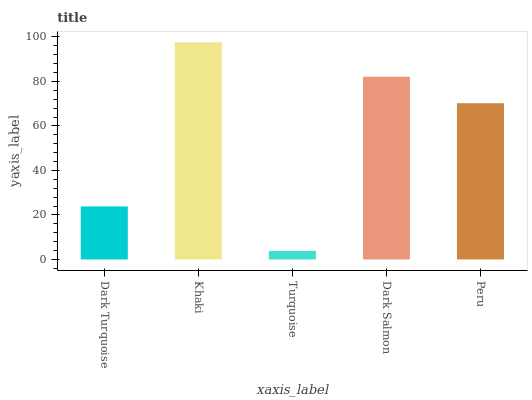Is Turquoise the minimum?
Answer yes or no. Yes. Is Khaki the maximum?
Answer yes or no. Yes. Is Khaki the minimum?
Answer yes or no. No. Is Turquoise the maximum?
Answer yes or no. No. Is Khaki greater than Turquoise?
Answer yes or no. Yes. Is Turquoise less than Khaki?
Answer yes or no. Yes. Is Turquoise greater than Khaki?
Answer yes or no. No. Is Khaki less than Turquoise?
Answer yes or no. No. Is Peru the high median?
Answer yes or no. Yes. Is Peru the low median?
Answer yes or no. Yes. Is Dark Turquoise the high median?
Answer yes or no. No. Is Turquoise the low median?
Answer yes or no. No. 